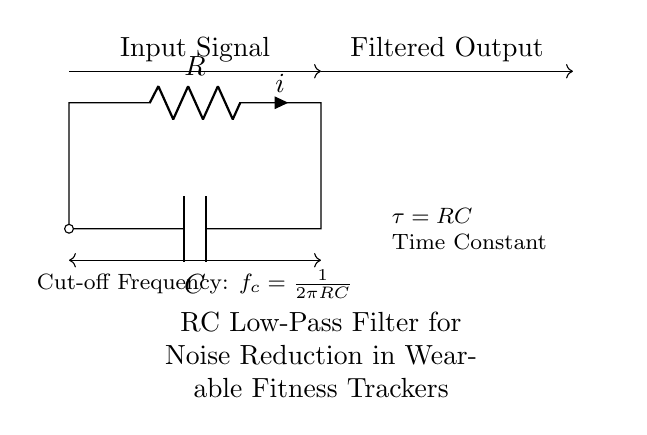What components are in this circuit? The circuit diagram shows a resistor and a capacitor connected to form a low-pass filter.
Answer: Resistor and capacitor What is the purpose of this circuit? This RC circuit serves as a low-pass filter to reduce noise in the input signal, allowing only lower frequencies to pass through.
Answer: Noise reduction What is the time constant (tau) of this circuit? The time constant, represented as tau, is the product of resistance and capacitance. In this circuit, it's labeled as RC.
Answer: RC What is the cut-off frequency formula for this circuit? The cut-off frequency formula is shown in the diagram as f_c equals one divided by two pi times the product of R and C.
Answer: f_c = 1/(2πRC) How does increasing the resistance value (R) affect the cut-off frequency? Increasing R decreases the cut-off frequency since f_c inversely depends on R in the formula. This means that lower frequencies are allowed to pass through.
Answer: Decreases cut-off frequency What happens to the output signal when the input signal has a higher frequency than the cut-off frequency? When the input signal has a frequency higher than the cut-off frequency, the signal is attenuated, resulting in a weaker output.
Answer: Signal is attenuated 